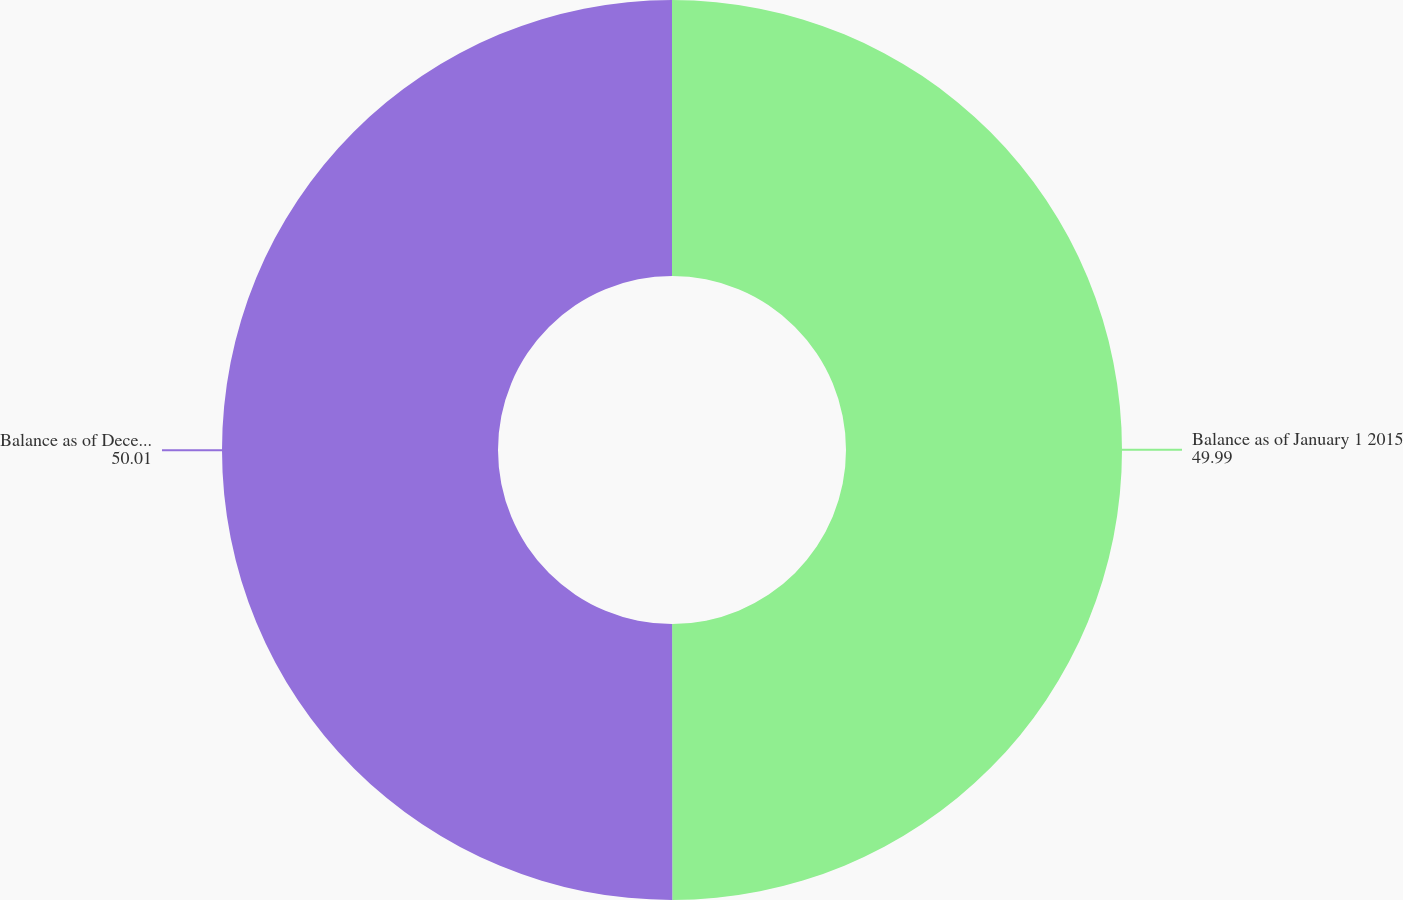<chart> <loc_0><loc_0><loc_500><loc_500><pie_chart><fcel>Balance as of January 1 2015<fcel>Balance as of December 31 2015<nl><fcel>49.99%<fcel>50.01%<nl></chart> 